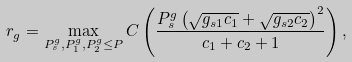<formula> <loc_0><loc_0><loc_500><loc_500>r _ { g } = \max _ { P _ { s } ^ { g } , P _ { 1 } ^ { g } , P _ { 2 } ^ { g } \leq P } C \left ( \frac { P _ { s } ^ { g } \left ( \sqrt { g _ { s 1 } c _ { 1 } } + \sqrt { g _ { s 2 } c _ { 2 } } \right ) ^ { 2 } } { c _ { 1 } + c _ { 2 } + 1 } \right ) ,</formula> 